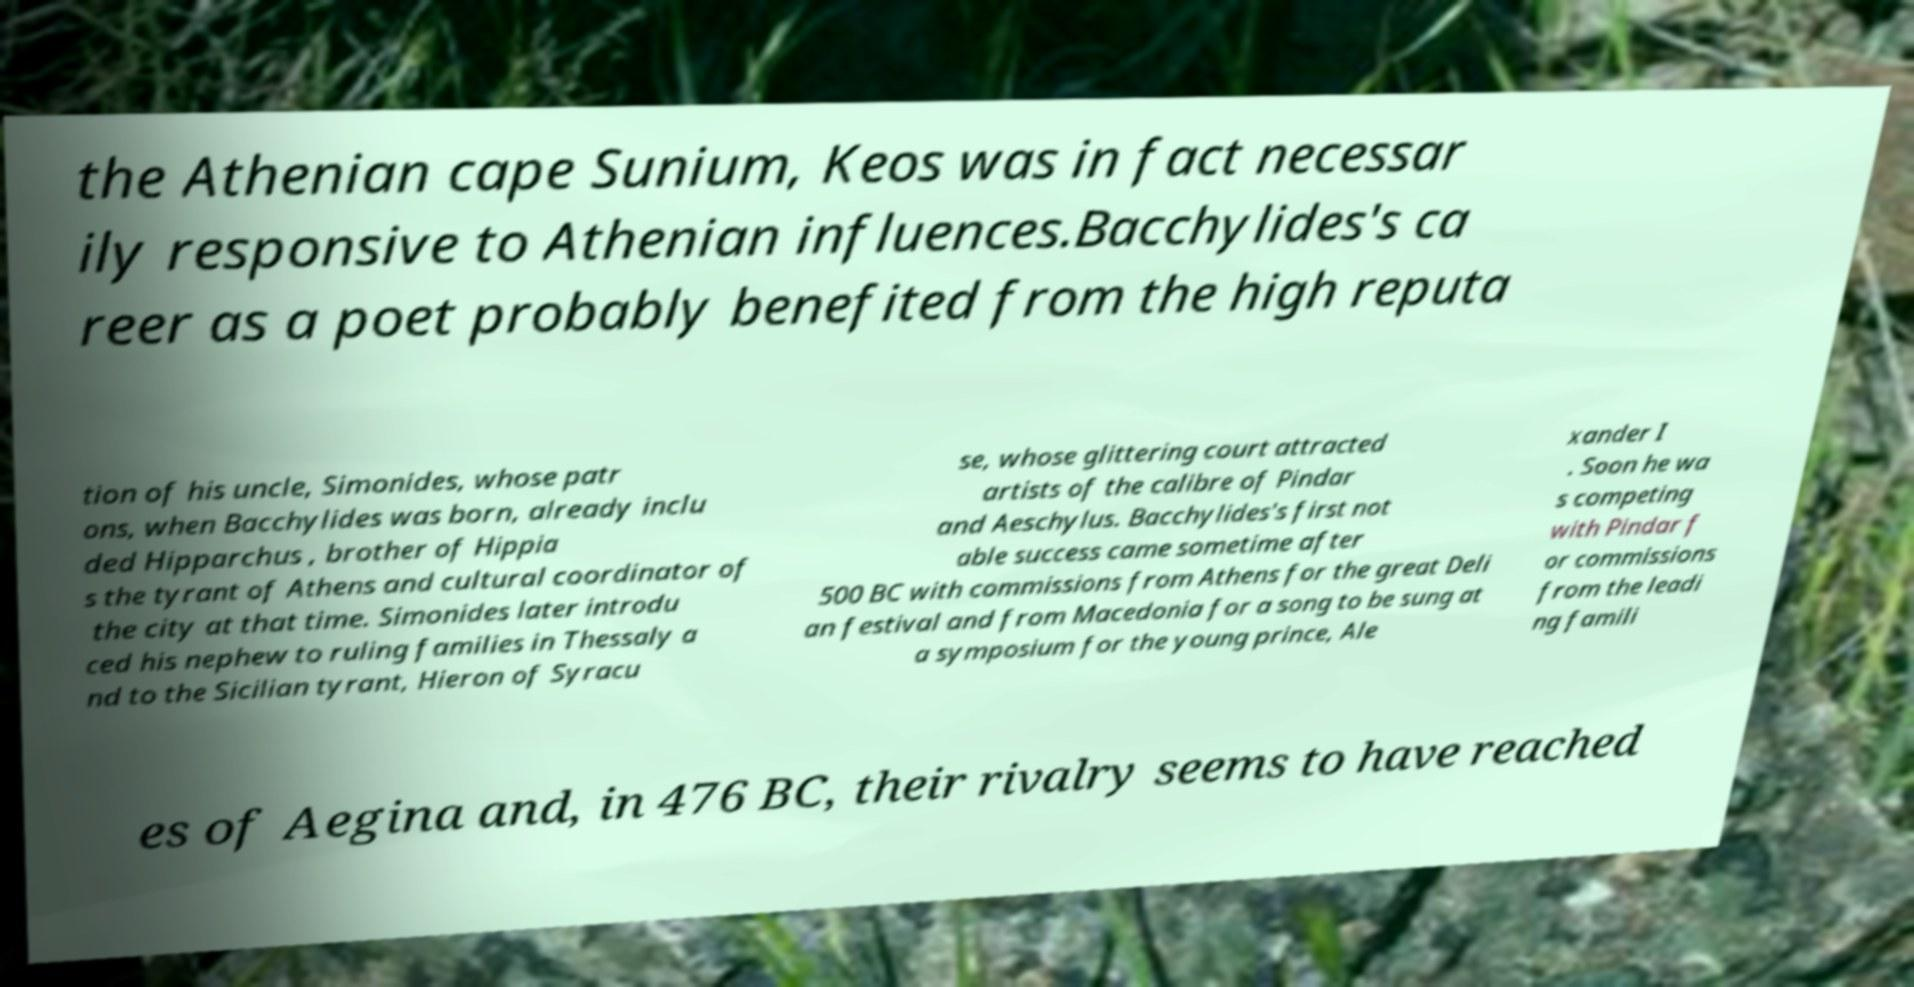Please read and relay the text visible in this image. What does it say? the Athenian cape Sunium, Keos was in fact necessar ily responsive to Athenian influences.Bacchylides's ca reer as a poet probably benefited from the high reputa tion of his uncle, Simonides, whose patr ons, when Bacchylides was born, already inclu ded Hipparchus , brother of Hippia s the tyrant of Athens and cultural coordinator of the city at that time. Simonides later introdu ced his nephew to ruling families in Thessaly a nd to the Sicilian tyrant, Hieron of Syracu se, whose glittering court attracted artists of the calibre of Pindar and Aeschylus. Bacchylides's first not able success came sometime after 500 BC with commissions from Athens for the great Deli an festival and from Macedonia for a song to be sung at a symposium for the young prince, Ale xander I . Soon he wa s competing with Pindar f or commissions from the leadi ng famili es of Aegina and, in 476 BC, their rivalry seems to have reached 